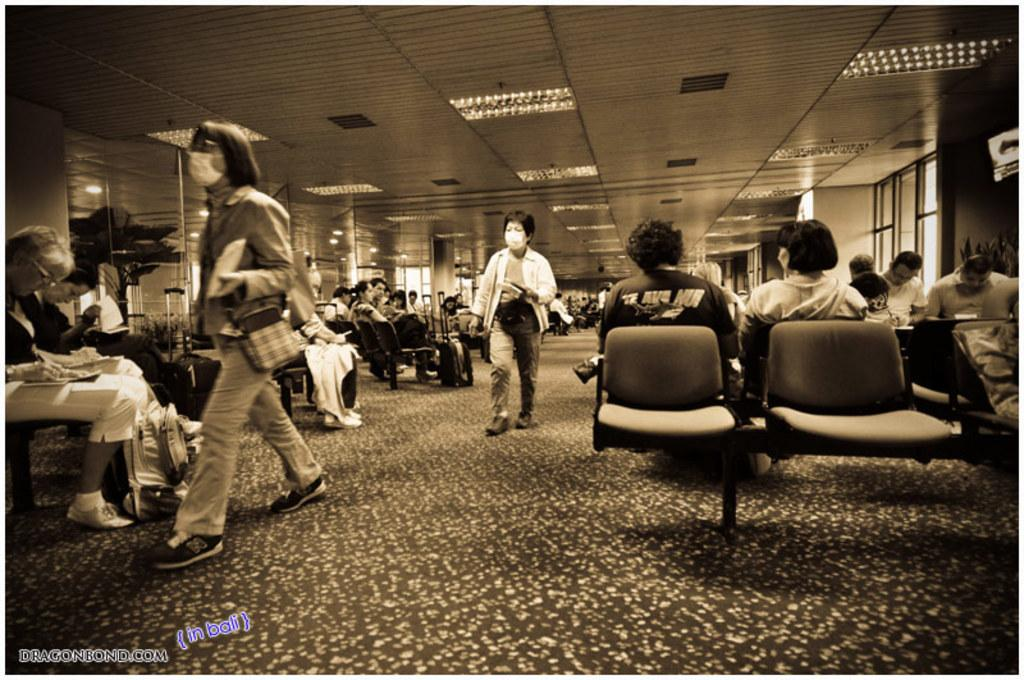What is the color scheme of the image? The image is black and white. What are the two people in the image doing? The two people in the image are walking. How can we tell that the people are walking? The walking people exhibit leg movement in the image. What is the primary activity of the majority of people in the image? Most of the people in the image are sitting on chairs. What grade of plough is being used by the people in the image? There is no plough present in the image; it features people walking and sitting on chairs. 